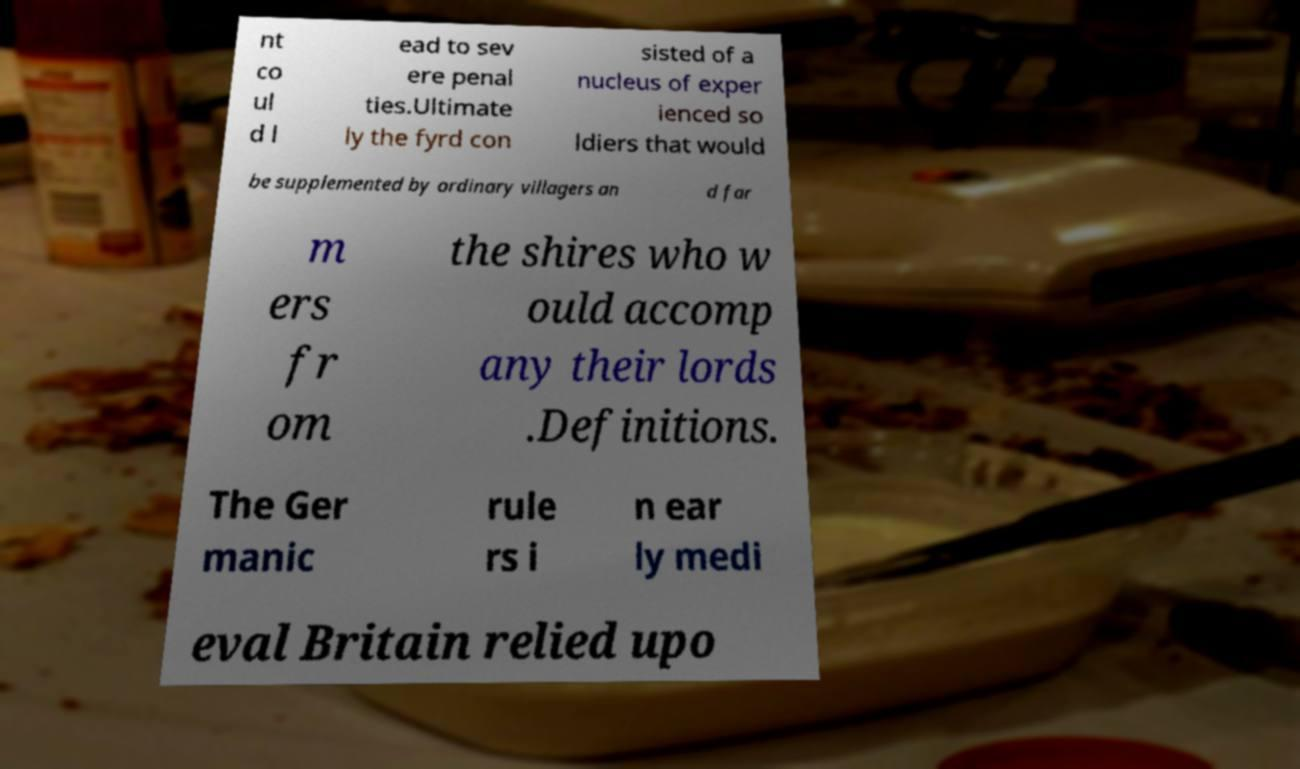Could you extract and type out the text from this image? nt co ul d l ead to sev ere penal ties.Ultimate ly the fyrd con sisted of a nucleus of exper ienced so ldiers that would be supplemented by ordinary villagers an d far m ers fr om the shires who w ould accomp any their lords .Definitions. The Ger manic rule rs i n ear ly medi eval Britain relied upo 